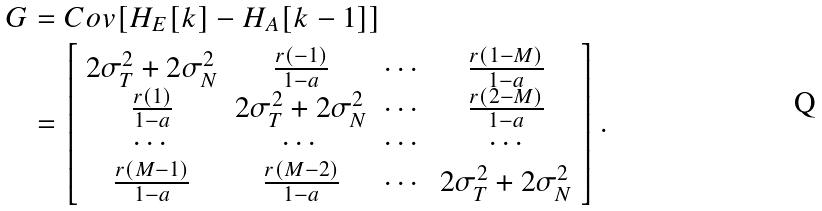<formula> <loc_0><loc_0><loc_500><loc_500>G & = C o v [ { H } _ { E } [ k ] - { H } _ { A } [ k - 1 ] ] \\ & = \left [ \begin{array} { c c c c } 2 \sigma _ { T } ^ { 2 } + 2 \sigma _ { N } ^ { 2 } & \frac { r ( - 1 ) } { 1 - a } & \cdots & \frac { r ( 1 - M ) } { 1 - a } \\ \frac { r ( 1 ) } { 1 - a } & 2 \sigma _ { T } ^ { 2 } + 2 \sigma _ { N } ^ { 2 } & \cdots & \frac { r ( 2 - M ) } { 1 - a } \\ \cdots & \cdots & \cdots & \cdots \\ \frac { r ( M - 1 ) } { 1 - a } & \frac { r ( M - 2 ) } { 1 - a } & \cdots & 2 \sigma _ { T } ^ { 2 } + 2 \sigma _ { N } ^ { 2 } \end{array} \right ] .</formula> 